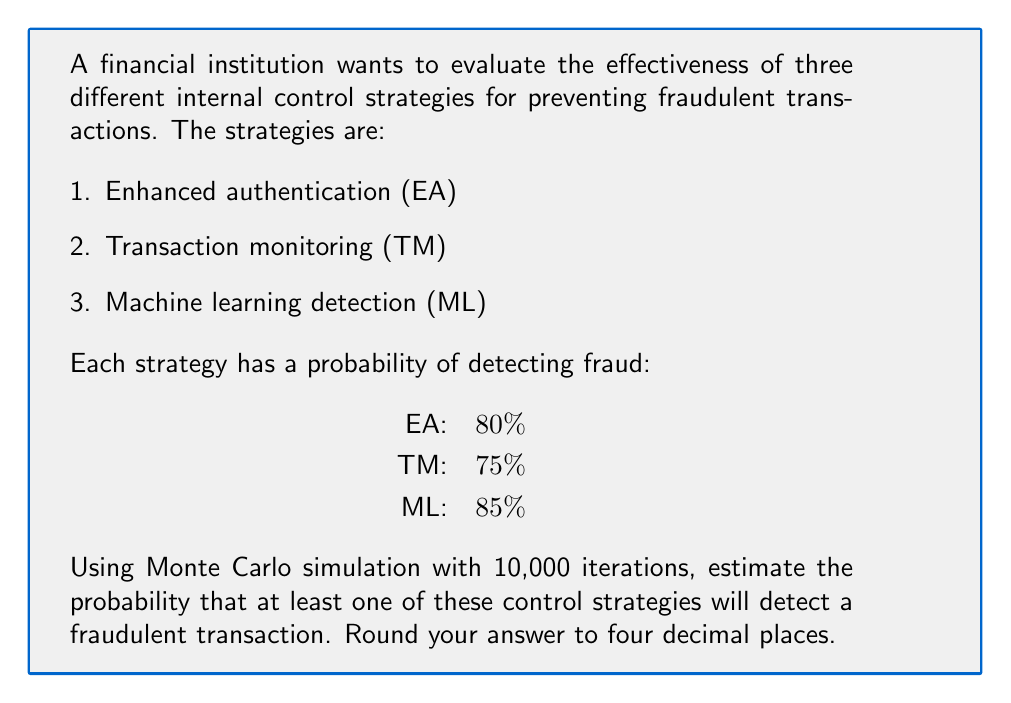Could you help me with this problem? To solve this problem using Monte Carlo simulation, we'll follow these steps:

1. Set up the simulation:
   - Number of iterations: 10,000
   - Control strategies: EA, TM, ML
   - Detection probabilities: 0.80, 0.75, 0.85

2. For each iteration:
   a. Generate random numbers for each strategy
   b. Check if any strategy detects the fraud
   c. Count successful detections

3. Calculate the final probability

Step 1: Set up the simulation
We'll use Python to run the simulation. Here's the code:

```python
import random

iterations = 10000
detections = 0

for _ in range(iterations):
    ea = random.random() < 0.80
    tm = random.random() < 0.75
    ml = random.random() < 0.85
    
    if ea or tm or ml:
        detections += 1

probability = detections / iterations
```

Step 2: Run the simulation
The code above simulates 10,000 fraudulent transactions. For each transaction, it checks if any of the three strategies detect the fraud.

Step 3: Calculate the final probability
After running the simulation, we divide the number of successful detections by the total number of iterations to get the probability.

The mathematical reasoning behind this approach is based on the complement of the probability that all strategies fail:

$$P(\text{at least one detects}) = 1 - P(\text{all fail})$$

$$P(\text{all fail}) = (1 - 0.80) \times (1 - 0.75) \times (1 - 0.85)$$

$$P(\text{all fail}) = 0.20 \times 0.25 \times 0.15 = 0.0075$$

$$P(\text{at least one detects}) = 1 - 0.0075 = 0.9925$$

The Monte Carlo simulation approximates this theoretical probability, with some variation due to randomness.
Answer: 0.9925 